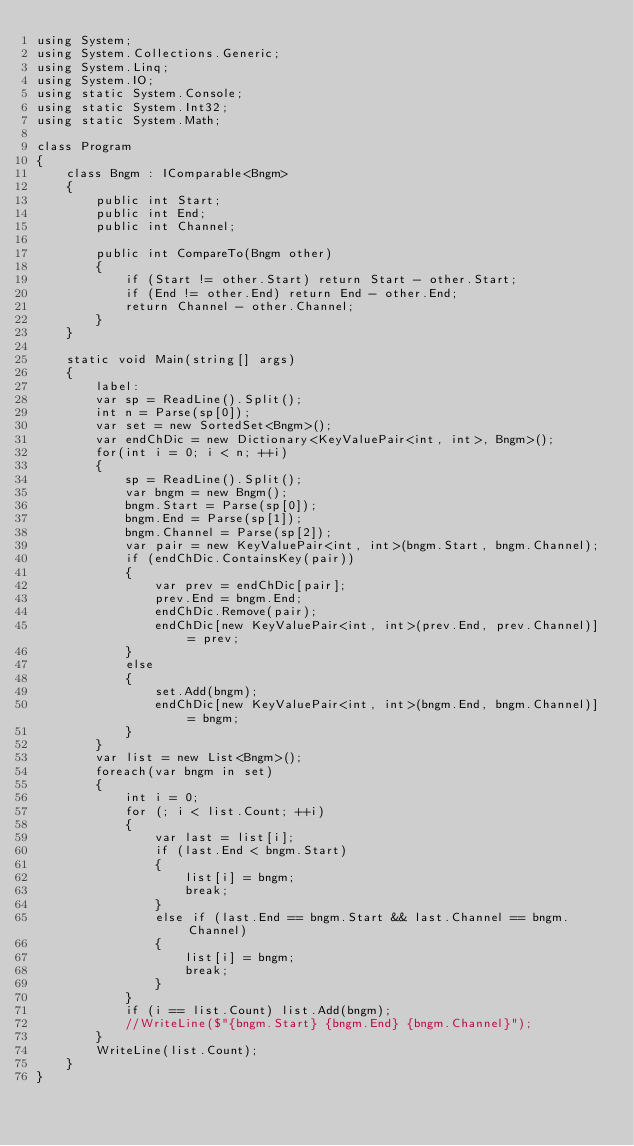Convert code to text. <code><loc_0><loc_0><loc_500><loc_500><_C#_>using System;
using System.Collections.Generic;
using System.Linq;
using System.IO;
using static System.Console;
using static System.Int32;
using static System.Math;
 
class Program
{
    class Bngm : IComparable<Bngm>
    {
        public int Start;
        public int End;
        public int Channel;

        public int CompareTo(Bngm other)
        {
            if (Start != other.Start) return Start - other.Start;
            if (End != other.End) return End - other.End;
            return Channel - other.Channel;
        }
    }

    static void Main(string[] args)
    {
        label:
        var sp = ReadLine().Split();
        int n = Parse(sp[0]);
        var set = new SortedSet<Bngm>();
        var endChDic = new Dictionary<KeyValuePair<int, int>, Bngm>();
        for(int i = 0; i < n; ++i)
        {
            sp = ReadLine().Split();
            var bngm = new Bngm();
            bngm.Start = Parse(sp[0]);
            bngm.End = Parse(sp[1]);
            bngm.Channel = Parse(sp[2]);
            var pair = new KeyValuePair<int, int>(bngm.Start, bngm.Channel);
            if (endChDic.ContainsKey(pair))
            {
                var prev = endChDic[pair];
                prev.End = bngm.End;
                endChDic.Remove(pair);
                endChDic[new KeyValuePair<int, int>(prev.End, prev.Channel)] = prev;
            }
            else
            {
                set.Add(bngm);
                endChDic[new KeyValuePair<int, int>(bngm.End, bngm.Channel)] = bngm;
            }
        }
        var list = new List<Bngm>();
        foreach(var bngm in set)
        {
            int i = 0;
            for (; i < list.Count; ++i)
            {
                var last = list[i];
                if (last.End < bngm.Start)
                {
                    list[i] = bngm;
                    break;
                }
                else if (last.End == bngm.Start && last.Channel == bngm.Channel)
                {
                    list[i] = bngm;
                    break;
                }
            }
            if (i == list.Count) list.Add(bngm);
            //WriteLine($"{bngm.Start} {bngm.End} {bngm.Channel}");
        }
        WriteLine(list.Count);
    }
}
</code> 